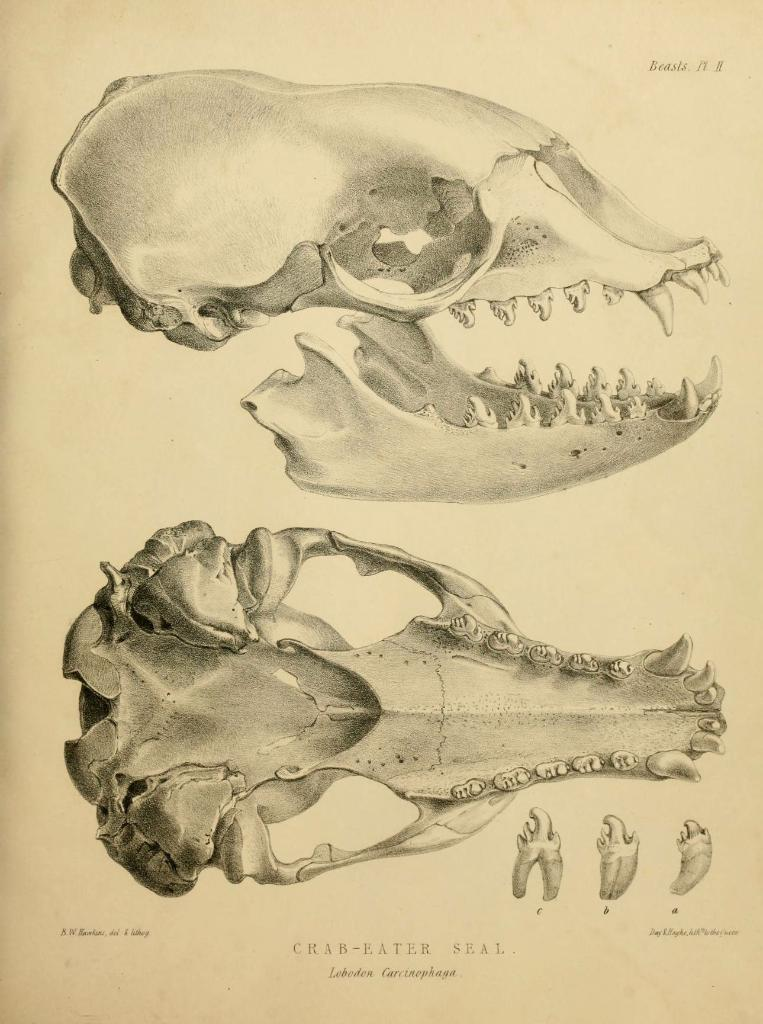What type of image is being described? The image is a drawing. What additional elements can be found on the drawing? There is text written on the drawing. What color is the mist surrounding the arch in the image? There is no mention of mist or an arch in the image; it is a drawing with text. 